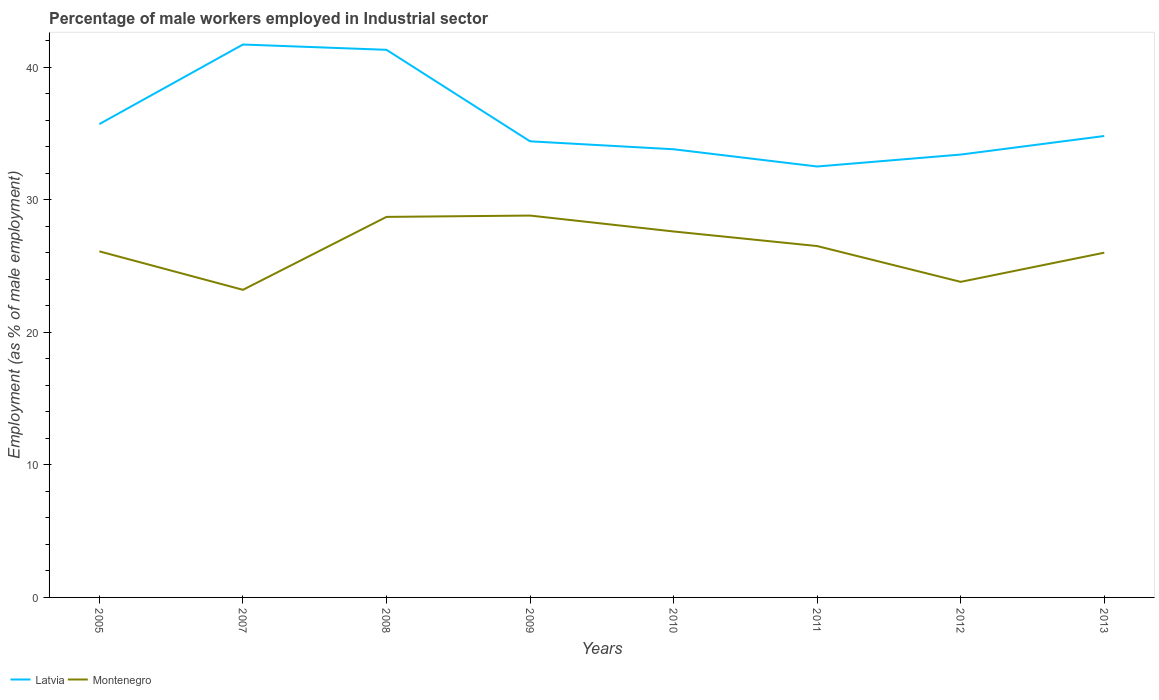How many different coloured lines are there?
Make the answer very short. 2. Does the line corresponding to Latvia intersect with the line corresponding to Montenegro?
Offer a terse response. No. Across all years, what is the maximum percentage of male workers employed in Industrial sector in Latvia?
Your answer should be very brief. 32.5. What is the difference between the highest and the second highest percentage of male workers employed in Industrial sector in Latvia?
Provide a short and direct response. 9.2. What is the difference between the highest and the lowest percentage of male workers employed in Industrial sector in Montenegro?
Keep it short and to the point. 4. How many years are there in the graph?
Provide a succinct answer. 8. What is the difference between two consecutive major ticks on the Y-axis?
Make the answer very short. 10. Are the values on the major ticks of Y-axis written in scientific E-notation?
Your response must be concise. No. Does the graph contain grids?
Ensure brevity in your answer.  No. Where does the legend appear in the graph?
Your response must be concise. Bottom left. What is the title of the graph?
Your response must be concise. Percentage of male workers employed in Industrial sector. Does "Cote d'Ivoire" appear as one of the legend labels in the graph?
Offer a very short reply. No. What is the label or title of the X-axis?
Your answer should be very brief. Years. What is the label or title of the Y-axis?
Provide a short and direct response. Employment (as % of male employment). What is the Employment (as % of male employment) in Latvia in 2005?
Provide a short and direct response. 35.7. What is the Employment (as % of male employment) of Montenegro in 2005?
Offer a very short reply. 26.1. What is the Employment (as % of male employment) of Latvia in 2007?
Give a very brief answer. 41.7. What is the Employment (as % of male employment) in Montenegro in 2007?
Ensure brevity in your answer.  23.2. What is the Employment (as % of male employment) of Latvia in 2008?
Offer a terse response. 41.3. What is the Employment (as % of male employment) in Montenegro in 2008?
Provide a short and direct response. 28.7. What is the Employment (as % of male employment) of Latvia in 2009?
Give a very brief answer. 34.4. What is the Employment (as % of male employment) of Montenegro in 2009?
Offer a very short reply. 28.8. What is the Employment (as % of male employment) in Latvia in 2010?
Your answer should be very brief. 33.8. What is the Employment (as % of male employment) in Montenegro in 2010?
Provide a short and direct response. 27.6. What is the Employment (as % of male employment) in Latvia in 2011?
Keep it short and to the point. 32.5. What is the Employment (as % of male employment) of Montenegro in 2011?
Your answer should be compact. 26.5. What is the Employment (as % of male employment) in Latvia in 2012?
Give a very brief answer. 33.4. What is the Employment (as % of male employment) in Montenegro in 2012?
Provide a succinct answer. 23.8. What is the Employment (as % of male employment) of Latvia in 2013?
Your answer should be very brief. 34.8. What is the Employment (as % of male employment) of Montenegro in 2013?
Keep it short and to the point. 26. Across all years, what is the maximum Employment (as % of male employment) in Latvia?
Provide a succinct answer. 41.7. Across all years, what is the maximum Employment (as % of male employment) in Montenegro?
Your answer should be compact. 28.8. Across all years, what is the minimum Employment (as % of male employment) in Latvia?
Make the answer very short. 32.5. Across all years, what is the minimum Employment (as % of male employment) of Montenegro?
Offer a terse response. 23.2. What is the total Employment (as % of male employment) of Latvia in the graph?
Your answer should be very brief. 287.6. What is the total Employment (as % of male employment) of Montenegro in the graph?
Provide a succinct answer. 210.7. What is the difference between the Employment (as % of male employment) of Montenegro in 2005 and that in 2008?
Make the answer very short. -2.6. What is the difference between the Employment (as % of male employment) in Montenegro in 2005 and that in 2011?
Your answer should be compact. -0.4. What is the difference between the Employment (as % of male employment) of Latvia in 2005 and that in 2012?
Provide a succinct answer. 2.3. What is the difference between the Employment (as % of male employment) of Latvia in 2005 and that in 2013?
Your answer should be compact. 0.9. What is the difference between the Employment (as % of male employment) of Montenegro in 2005 and that in 2013?
Your answer should be compact. 0.1. What is the difference between the Employment (as % of male employment) in Latvia in 2007 and that in 2009?
Keep it short and to the point. 7.3. What is the difference between the Employment (as % of male employment) of Montenegro in 2007 and that in 2009?
Your response must be concise. -5.6. What is the difference between the Employment (as % of male employment) in Montenegro in 2007 and that in 2011?
Your answer should be very brief. -3.3. What is the difference between the Employment (as % of male employment) in Latvia in 2007 and that in 2012?
Ensure brevity in your answer.  8.3. What is the difference between the Employment (as % of male employment) of Latvia in 2007 and that in 2013?
Make the answer very short. 6.9. What is the difference between the Employment (as % of male employment) in Montenegro in 2007 and that in 2013?
Make the answer very short. -2.8. What is the difference between the Employment (as % of male employment) of Latvia in 2008 and that in 2010?
Your answer should be very brief. 7.5. What is the difference between the Employment (as % of male employment) of Montenegro in 2008 and that in 2010?
Your answer should be very brief. 1.1. What is the difference between the Employment (as % of male employment) in Latvia in 2008 and that in 2011?
Your answer should be compact. 8.8. What is the difference between the Employment (as % of male employment) in Latvia in 2008 and that in 2012?
Ensure brevity in your answer.  7.9. What is the difference between the Employment (as % of male employment) in Latvia in 2008 and that in 2013?
Your answer should be very brief. 6.5. What is the difference between the Employment (as % of male employment) in Latvia in 2009 and that in 2011?
Offer a very short reply. 1.9. What is the difference between the Employment (as % of male employment) in Montenegro in 2009 and that in 2011?
Your response must be concise. 2.3. What is the difference between the Employment (as % of male employment) in Latvia in 2009 and that in 2012?
Provide a short and direct response. 1. What is the difference between the Employment (as % of male employment) of Montenegro in 2009 and that in 2012?
Your response must be concise. 5. What is the difference between the Employment (as % of male employment) in Montenegro in 2009 and that in 2013?
Ensure brevity in your answer.  2.8. What is the difference between the Employment (as % of male employment) of Latvia in 2010 and that in 2011?
Keep it short and to the point. 1.3. What is the difference between the Employment (as % of male employment) in Montenegro in 2010 and that in 2011?
Make the answer very short. 1.1. What is the difference between the Employment (as % of male employment) in Latvia in 2010 and that in 2012?
Keep it short and to the point. 0.4. What is the difference between the Employment (as % of male employment) of Montenegro in 2010 and that in 2012?
Your answer should be compact. 3.8. What is the difference between the Employment (as % of male employment) of Latvia in 2011 and that in 2012?
Your response must be concise. -0.9. What is the difference between the Employment (as % of male employment) of Montenegro in 2011 and that in 2012?
Your answer should be very brief. 2.7. What is the difference between the Employment (as % of male employment) of Latvia in 2012 and that in 2013?
Your answer should be very brief. -1.4. What is the difference between the Employment (as % of male employment) in Latvia in 2005 and the Employment (as % of male employment) in Montenegro in 2010?
Your answer should be compact. 8.1. What is the difference between the Employment (as % of male employment) in Latvia in 2005 and the Employment (as % of male employment) in Montenegro in 2012?
Your answer should be compact. 11.9. What is the difference between the Employment (as % of male employment) in Latvia in 2007 and the Employment (as % of male employment) in Montenegro in 2008?
Your response must be concise. 13. What is the difference between the Employment (as % of male employment) of Latvia in 2007 and the Employment (as % of male employment) of Montenegro in 2010?
Your answer should be compact. 14.1. What is the difference between the Employment (as % of male employment) of Latvia in 2007 and the Employment (as % of male employment) of Montenegro in 2012?
Make the answer very short. 17.9. What is the difference between the Employment (as % of male employment) of Latvia in 2008 and the Employment (as % of male employment) of Montenegro in 2011?
Make the answer very short. 14.8. What is the difference between the Employment (as % of male employment) in Latvia in 2008 and the Employment (as % of male employment) in Montenegro in 2013?
Your answer should be compact. 15.3. What is the difference between the Employment (as % of male employment) in Latvia in 2010 and the Employment (as % of male employment) in Montenegro in 2012?
Offer a very short reply. 10. What is the difference between the Employment (as % of male employment) of Latvia in 2012 and the Employment (as % of male employment) of Montenegro in 2013?
Provide a short and direct response. 7.4. What is the average Employment (as % of male employment) of Latvia per year?
Provide a succinct answer. 35.95. What is the average Employment (as % of male employment) in Montenegro per year?
Give a very brief answer. 26.34. In the year 2008, what is the difference between the Employment (as % of male employment) of Latvia and Employment (as % of male employment) of Montenegro?
Provide a short and direct response. 12.6. In the year 2009, what is the difference between the Employment (as % of male employment) of Latvia and Employment (as % of male employment) of Montenegro?
Provide a succinct answer. 5.6. In the year 2012, what is the difference between the Employment (as % of male employment) in Latvia and Employment (as % of male employment) in Montenegro?
Keep it short and to the point. 9.6. What is the ratio of the Employment (as % of male employment) in Latvia in 2005 to that in 2007?
Give a very brief answer. 0.86. What is the ratio of the Employment (as % of male employment) of Montenegro in 2005 to that in 2007?
Your answer should be compact. 1.12. What is the ratio of the Employment (as % of male employment) in Latvia in 2005 to that in 2008?
Provide a succinct answer. 0.86. What is the ratio of the Employment (as % of male employment) in Montenegro in 2005 to that in 2008?
Give a very brief answer. 0.91. What is the ratio of the Employment (as % of male employment) of Latvia in 2005 to that in 2009?
Give a very brief answer. 1.04. What is the ratio of the Employment (as % of male employment) of Montenegro in 2005 to that in 2009?
Your answer should be very brief. 0.91. What is the ratio of the Employment (as % of male employment) of Latvia in 2005 to that in 2010?
Give a very brief answer. 1.06. What is the ratio of the Employment (as % of male employment) in Montenegro in 2005 to that in 2010?
Ensure brevity in your answer.  0.95. What is the ratio of the Employment (as % of male employment) in Latvia in 2005 to that in 2011?
Your response must be concise. 1.1. What is the ratio of the Employment (as % of male employment) of Montenegro in 2005 to that in 2011?
Your response must be concise. 0.98. What is the ratio of the Employment (as % of male employment) of Latvia in 2005 to that in 2012?
Your answer should be compact. 1.07. What is the ratio of the Employment (as % of male employment) in Montenegro in 2005 to that in 2012?
Provide a short and direct response. 1.1. What is the ratio of the Employment (as % of male employment) of Latvia in 2005 to that in 2013?
Give a very brief answer. 1.03. What is the ratio of the Employment (as % of male employment) in Montenegro in 2005 to that in 2013?
Keep it short and to the point. 1. What is the ratio of the Employment (as % of male employment) of Latvia in 2007 to that in 2008?
Make the answer very short. 1.01. What is the ratio of the Employment (as % of male employment) in Montenegro in 2007 to that in 2008?
Your response must be concise. 0.81. What is the ratio of the Employment (as % of male employment) in Latvia in 2007 to that in 2009?
Your answer should be compact. 1.21. What is the ratio of the Employment (as % of male employment) in Montenegro in 2007 to that in 2009?
Ensure brevity in your answer.  0.81. What is the ratio of the Employment (as % of male employment) of Latvia in 2007 to that in 2010?
Give a very brief answer. 1.23. What is the ratio of the Employment (as % of male employment) of Montenegro in 2007 to that in 2010?
Your response must be concise. 0.84. What is the ratio of the Employment (as % of male employment) of Latvia in 2007 to that in 2011?
Provide a short and direct response. 1.28. What is the ratio of the Employment (as % of male employment) of Montenegro in 2007 to that in 2011?
Provide a short and direct response. 0.88. What is the ratio of the Employment (as % of male employment) of Latvia in 2007 to that in 2012?
Offer a terse response. 1.25. What is the ratio of the Employment (as % of male employment) in Montenegro in 2007 to that in 2012?
Your answer should be very brief. 0.97. What is the ratio of the Employment (as % of male employment) of Latvia in 2007 to that in 2013?
Provide a short and direct response. 1.2. What is the ratio of the Employment (as % of male employment) in Montenegro in 2007 to that in 2013?
Provide a succinct answer. 0.89. What is the ratio of the Employment (as % of male employment) in Latvia in 2008 to that in 2009?
Make the answer very short. 1.2. What is the ratio of the Employment (as % of male employment) in Latvia in 2008 to that in 2010?
Provide a short and direct response. 1.22. What is the ratio of the Employment (as % of male employment) of Montenegro in 2008 to that in 2010?
Your answer should be very brief. 1.04. What is the ratio of the Employment (as % of male employment) in Latvia in 2008 to that in 2011?
Make the answer very short. 1.27. What is the ratio of the Employment (as % of male employment) of Montenegro in 2008 to that in 2011?
Keep it short and to the point. 1.08. What is the ratio of the Employment (as % of male employment) of Latvia in 2008 to that in 2012?
Make the answer very short. 1.24. What is the ratio of the Employment (as % of male employment) in Montenegro in 2008 to that in 2012?
Ensure brevity in your answer.  1.21. What is the ratio of the Employment (as % of male employment) of Latvia in 2008 to that in 2013?
Your answer should be very brief. 1.19. What is the ratio of the Employment (as % of male employment) in Montenegro in 2008 to that in 2013?
Keep it short and to the point. 1.1. What is the ratio of the Employment (as % of male employment) in Latvia in 2009 to that in 2010?
Provide a short and direct response. 1.02. What is the ratio of the Employment (as % of male employment) of Montenegro in 2009 to that in 2010?
Offer a terse response. 1.04. What is the ratio of the Employment (as % of male employment) in Latvia in 2009 to that in 2011?
Offer a terse response. 1.06. What is the ratio of the Employment (as % of male employment) in Montenegro in 2009 to that in 2011?
Your answer should be very brief. 1.09. What is the ratio of the Employment (as % of male employment) of Latvia in 2009 to that in 2012?
Provide a short and direct response. 1.03. What is the ratio of the Employment (as % of male employment) of Montenegro in 2009 to that in 2012?
Keep it short and to the point. 1.21. What is the ratio of the Employment (as % of male employment) of Montenegro in 2009 to that in 2013?
Your response must be concise. 1.11. What is the ratio of the Employment (as % of male employment) of Latvia in 2010 to that in 2011?
Give a very brief answer. 1.04. What is the ratio of the Employment (as % of male employment) of Montenegro in 2010 to that in 2011?
Offer a terse response. 1.04. What is the ratio of the Employment (as % of male employment) in Montenegro in 2010 to that in 2012?
Ensure brevity in your answer.  1.16. What is the ratio of the Employment (as % of male employment) in Latvia in 2010 to that in 2013?
Keep it short and to the point. 0.97. What is the ratio of the Employment (as % of male employment) in Montenegro in 2010 to that in 2013?
Ensure brevity in your answer.  1.06. What is the ratio of the Employment (as % of male employment) in Latvia in 2011 to that in 2012?
Your answer should be compact. 0.97. What is the ratio of the Employment (as % of male employment) of Montenegro in 2011 to that in 2012?
Provide a short and direct response. 1.11. What is the ratio of the Employment (as % of male employment) in Latvia in 2011 to that in 2013?
Your answer should be compact. 0.93. What is the ratio of the Employment (as % of male employment) of Montenegro in 2011 to that in 2013?
Keep it short and to the point. 1.02. What is the ratio of the Employment (as % of male employment) in Latvia in 2012 to that in 2013?
Offer a terse response. 0.96. What is the ratio of the Employment (as % of male employment) in Montenegro in 2012 to that in 2013?
Ensure brevity in your answer.  0.92. What is the difference between the highest and the lowest Employment (as % of male employment) of Latvia?
Give a very brief answer. 9.2. What is the difference between the highest and the lowest Employment (as % of male employment) in Montenegro?
Keep it short and to the point. 5.6. 